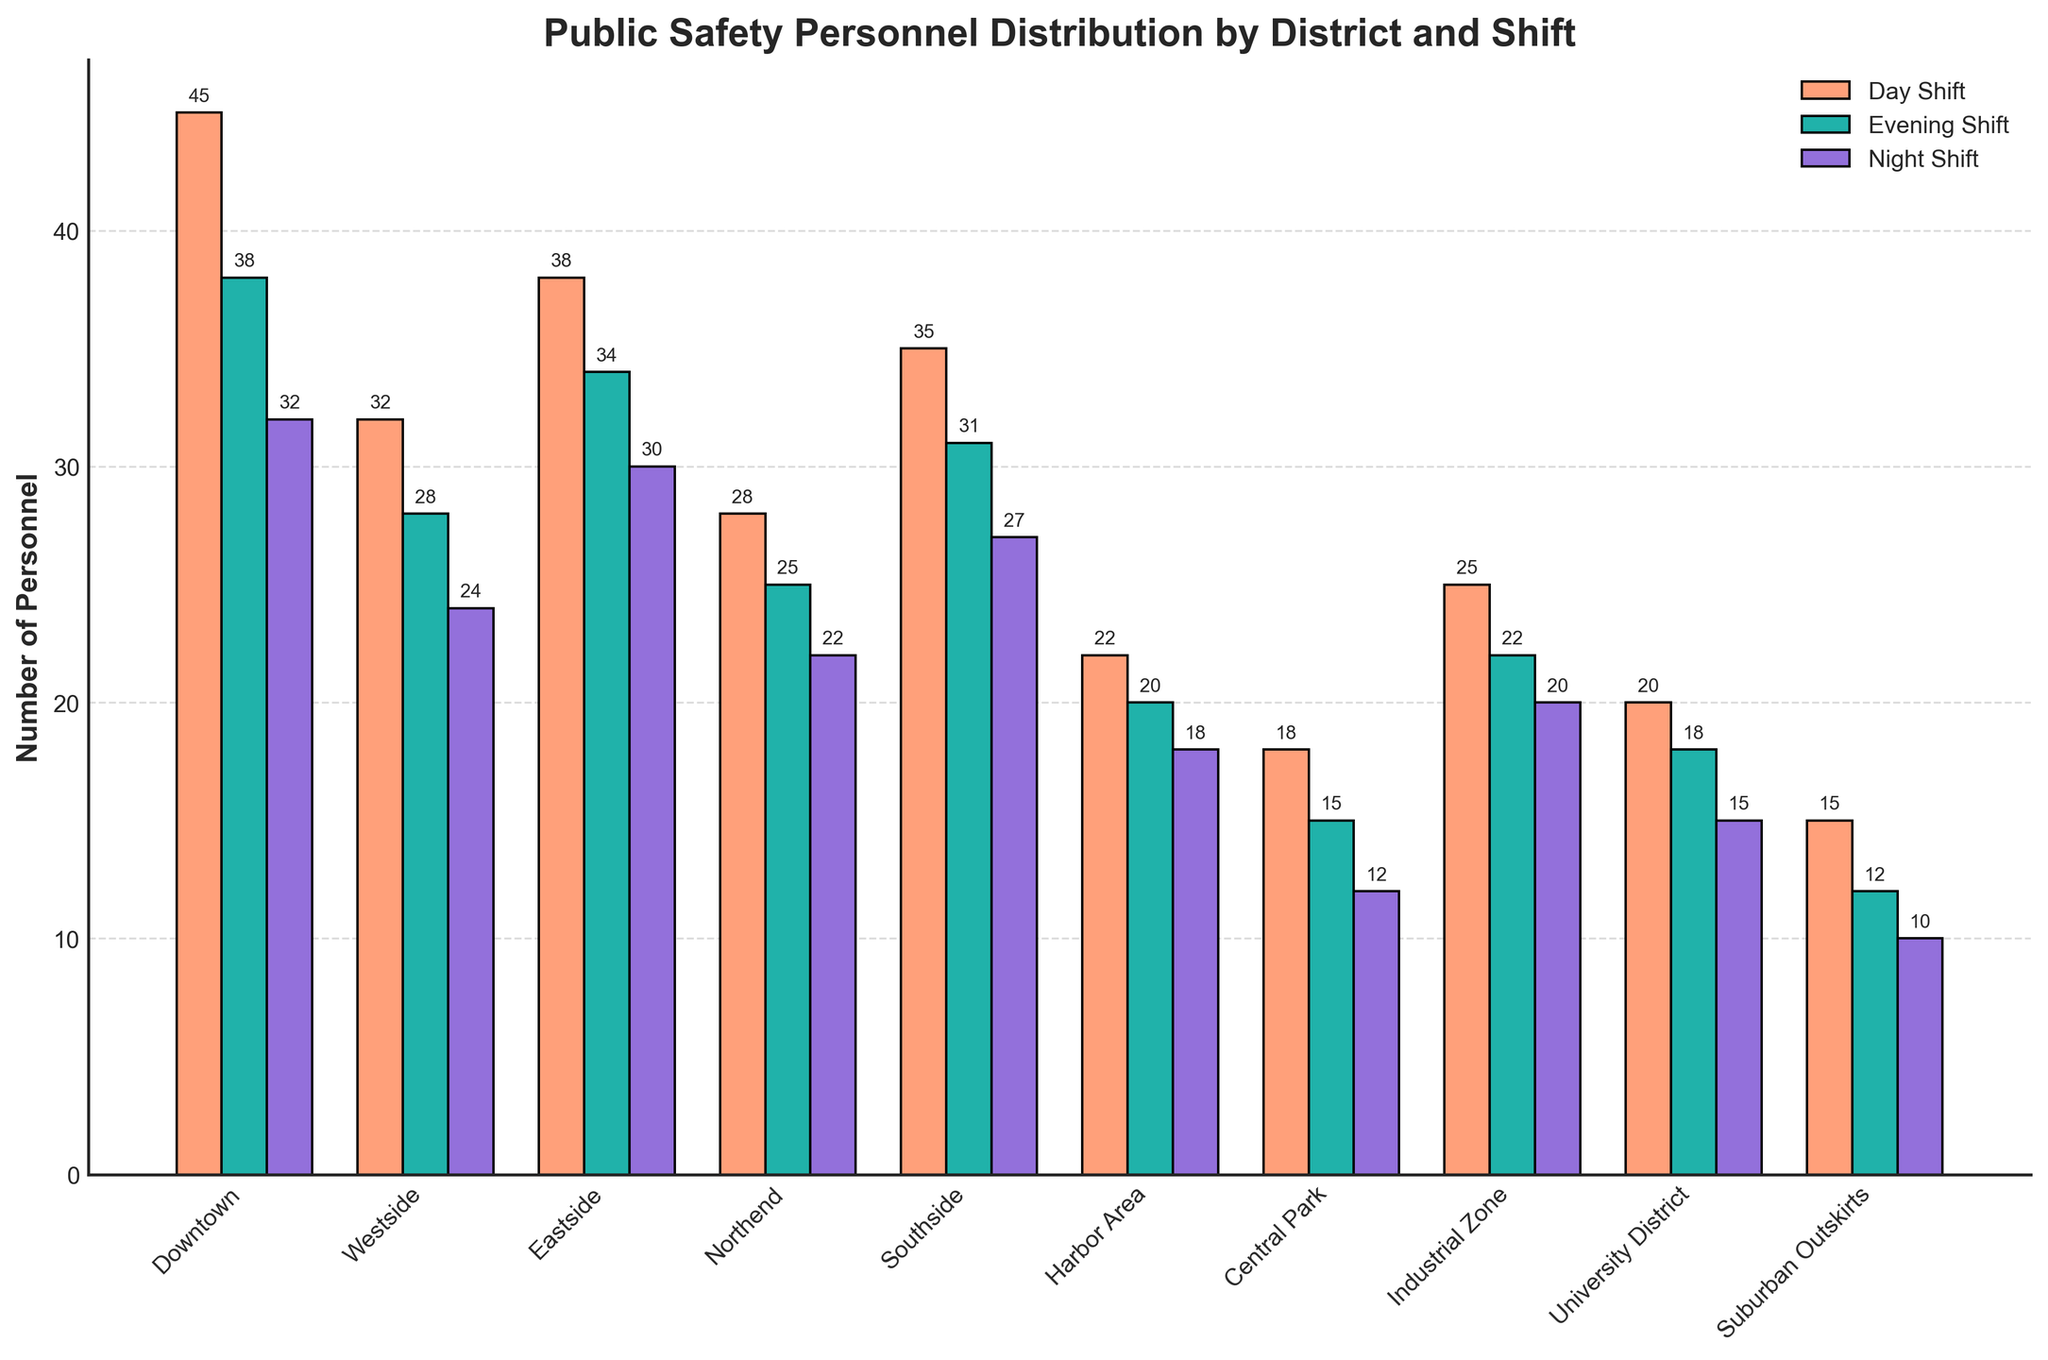Which district has the highest number of personnel in the Day Shift? The bar representing the Day Shift for each district is shown in a different color (salmon). By comparing the heights of these bars, we see that the tallest bar for the Day Shift corresponds to the Downtown district.
Answer: Downtown How many more personnel are there in the Evening Shift compared to the Night Shift in the Eastside district? The number of personnel for the Evening Shift in the Eastside district is 34, and for the Night Shift, it is 30. 34 - 30 equals 4.
Answer: 4 Which shift has the smallest number of personnel overall in Central Park? The bars for Central Park in the different shifts show the following heights: Day Shift (18), Evening Shift (15), and Night Shift (12). The smallest value is 12, which corresponds to the Night Shift.
Answer: Night Shift What is the total number of personnel in the Harbor Area district across all shifts? Summing the personnel for the Day Shift, Evening Shift, and Night Shift in the Harbor Area (22 + 20 + 18) gives a total of 60.
Answer: 60 In which district is the difference between the number of personnel in the Day and Night Shifts the largest? Calculate the difference between the Day and Night Shifts for each district. The differences are: 
- Downtown: 45 - 32 = 13
- Westside: 32 - 24 = 8
- Eastside: 38 - 30 = 8
- Northend: 28 - 22 = 6
- Southside: 35 - 27 = 8
- Harbor Area: 22 - 18 = 4
- Central Park: 18 - 12 = 6
- Industrial Zone: 25 - 20 = 5
- University District: 20 - 15 = 5
- Suburban Outskirts: 15 - 10 = 5
The largest difference is 13, which occurs in the Downtown district.
Answer: Downtown Which color represents the Evening Shift in the bar plot? The Evening Shift is represented by teal-colored bars, as indicated by the legend (it's marked 'Evening Shift').
Answer: Teal What is the average number of personnel in the Night Shift across all districts? Sum the number of personnel in the Night Shift across all districts (32 + 24 + 30 + 22 + 27 + 18 + 12 + 20 + 15 + 10 = 210) and divide by the number of districts (10), which gives an average of 210 / 10 = 21.
Answer: 21 How does the number of personnel in the Southside Evening Shift compare to the Northend Day Shift? The bar for the Southside district in the Evening Shift is lower than the bar for the Northend district in the Day Shift. Specifically, Southside Evening Shift (31) and Northend Day Shift (28). Therefore, Southside Evening Shift has more personnel.
Answer: Southside Evening Shift has more personnel Which district has the least personnel in the Day Shift and how many do they have? By comparing the heights of the bars representing the Day Shift, the shortest bar is for the Suburban Outskirts district, consisting of 15 personnel.
Answer: Suburban Outskirts, 15 How many districts have at least 30 personnel in the Day Shift? From the bars indicating the Day Shift, we count the districts with at least 30 personnel: Downtown (45), Eastside (38), Southside (35). There are 3 districts meeting this criterion.
Answer: 3 